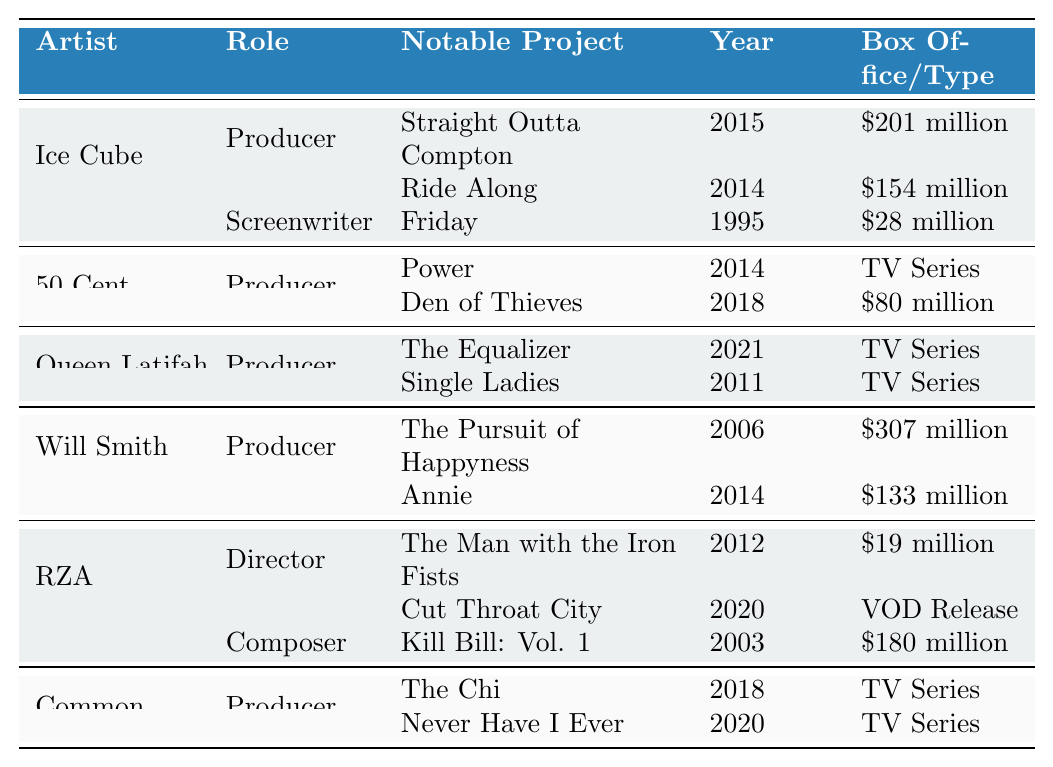What are the notable projects produced by Ice Cube? According to the table, Ice Cube produced two notable projects: "Straight Outta Compton" in 2015 with a box office of $201 million and "Ride Along" in 2014 with a box office of $154 million.
Answer: "Straight Outta Compton", "Ride Along" How many film production roles did RZA take on? The table shows that RZA took on three film production roles: two as a Director and one as a Composer.
Answer: 3 Which artist had the highest box office earnings for a single project? By checking the box office figures, Will Smith's "The Pursuit of Happyness" had the highest earnings at $307 million.
Answer: Will Smith Did Queen Latifah and Common produce any similar types of projects? Analyzing the table, both Queen Latifah and Common produced TV Series. Queen Latifah produced "The Equalizer" and "Single Ladies," while Common produced "The Chi" and "Never Have I Ever."
Answer: Yes What is the total box office revenue for Ice Cube's produced projects? Ice Cube's notable projects have total box office earnings of $201 million (Straight Outta Compton) + $154 million (Ride Along) = $355 million.
Answer: $355 million Which artist contributed as both a producer and a composer? Looking at the table, RZA is the artist who contributed as both a Director and a Composer, showing versatility in his film production roles.
Answer: RZA How many notable projects did 50 Cent produce that had a box office earnings listed? The table shows 50 Cent produced only one project with listed box office earnings: "Den of Thieves," which earned $80 million.
Answer: 1 Which roles did Ice Cube fill in film production based on the table? Ice Cube filled the roles of Producer and Screenwriter as per the table, indicating his diverse contributions to film production.
Answer: Producer, Screenwriter What is the box office difference between Will Smith's two notable projects? Will Smith's projects "The Pursuit of Happyness" earned $307 million and "Annie" earned $133 million, so the difference is $307 million - $133 million = $174 million.
Answer: $174 million Was any of RZA's notable projects released directly to VOD? Yes, according to the table, RZA's project "Cut Throat City" was released as a VOD release.
Answer: Yes 